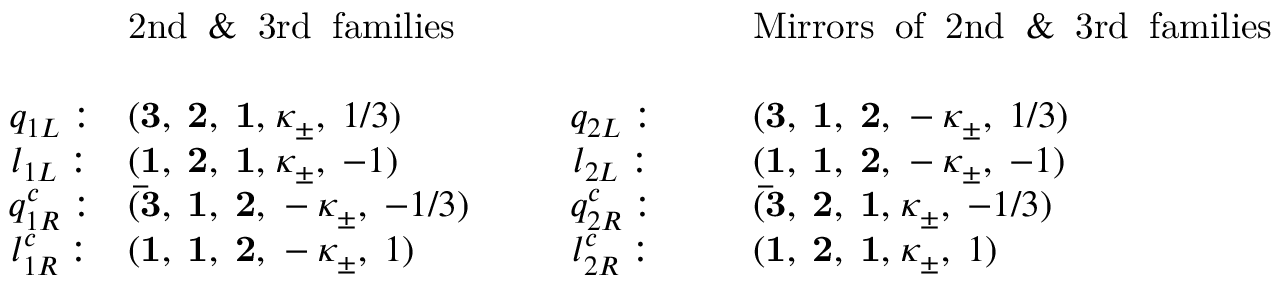<formula> <loc_0><loc_0><loc_500><loc_500>\begin{array} { c l c l & { 2 n d \, \& \, 3 r d \, f a m i l i e s } & { M i r r o r s \, o f \, 2 n d \, \& \, 3 r d \, f a m i l i e s } \\ { { q _ { 1 L } \colon } } & { { ( { 3 , \, 2 , \, 1 , } \, \kappa _ { \pm } , \, 1 / 3 ) } } & { { q _ { 2 L } \colon } } & { { ( { 3 , \, 1 , \, 2 , } \, - \kappa _ { \pm } , \, 1 / 3 ) \ } } \\ { { l _ { 1 L } \colon } } & { { ( { 1 , \, 2 , \, 1 , } \, \kappa _ { \pm } , \, - 1 ) } } & { { l _ { 2 L } \colon } } & { { ( { 1 , \, 1 , \, 2 , } \, - \kappa _ { \pm } , \, - 1 ) \ } } \\ { { q _ { 1 R } ^ { c } \colon } } & { { ( { \bar { 3 } , \, 1 , \, 2 , } \, - \kappa _ { \pm } , \, - 1 / 3 ) } } & { { q _ { 2 R } ^ { c } \colon } } & { { ( { \bar { 3 } , \, 2 , \, 1 , } \, \kappa _ { \pm } , \, - 1 / 3 ) \ } } \\ { { l _ { 1 R } ^ { c } \colon } } & { { ( { 1 , \, 1 , \, 2 , } \, - \kappa _ { \pm } , \, 1 ) } } & { { l _ { 2 R } ^ { c } \colon } } & { { ( { 1 , \, 2 , \, 1 , } \, \kappa _ { \pm } , \, 1 ) } } \end{array}</formula> 